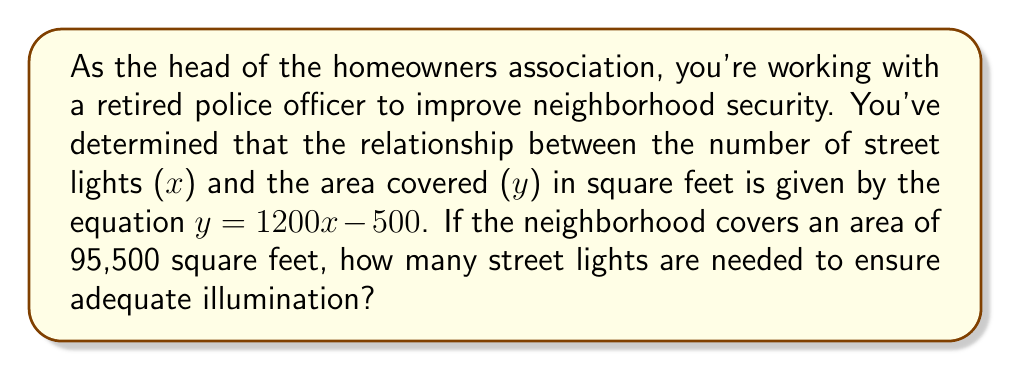Help me with this question. To solve this problem, we'll follow these steps:

1) We're given the linear equation: $y = 1200x - 500$
   Where $x$ is the number of street lights and $y$ is the area covered in square feet.

2) We know the total area to be covered is 95,500 square feet. Let's substitute this for $y$:

   $95500 = 1200x - 500$

3) Now, we need to solve this equation for $x$:

   $95500 + 500 = 1200x$
   $96000 = 1200x$

4) Divide both sides by 1200:

   $\frac{96000}{1200} = x$
   $80 = x$

5) Since we can't install a fraction of a street light, we need to round up to the nearest whole number.

Therefore, 80 street lights are needed to adequately illuminate the neighborhood.
Answer: 80 street lights 